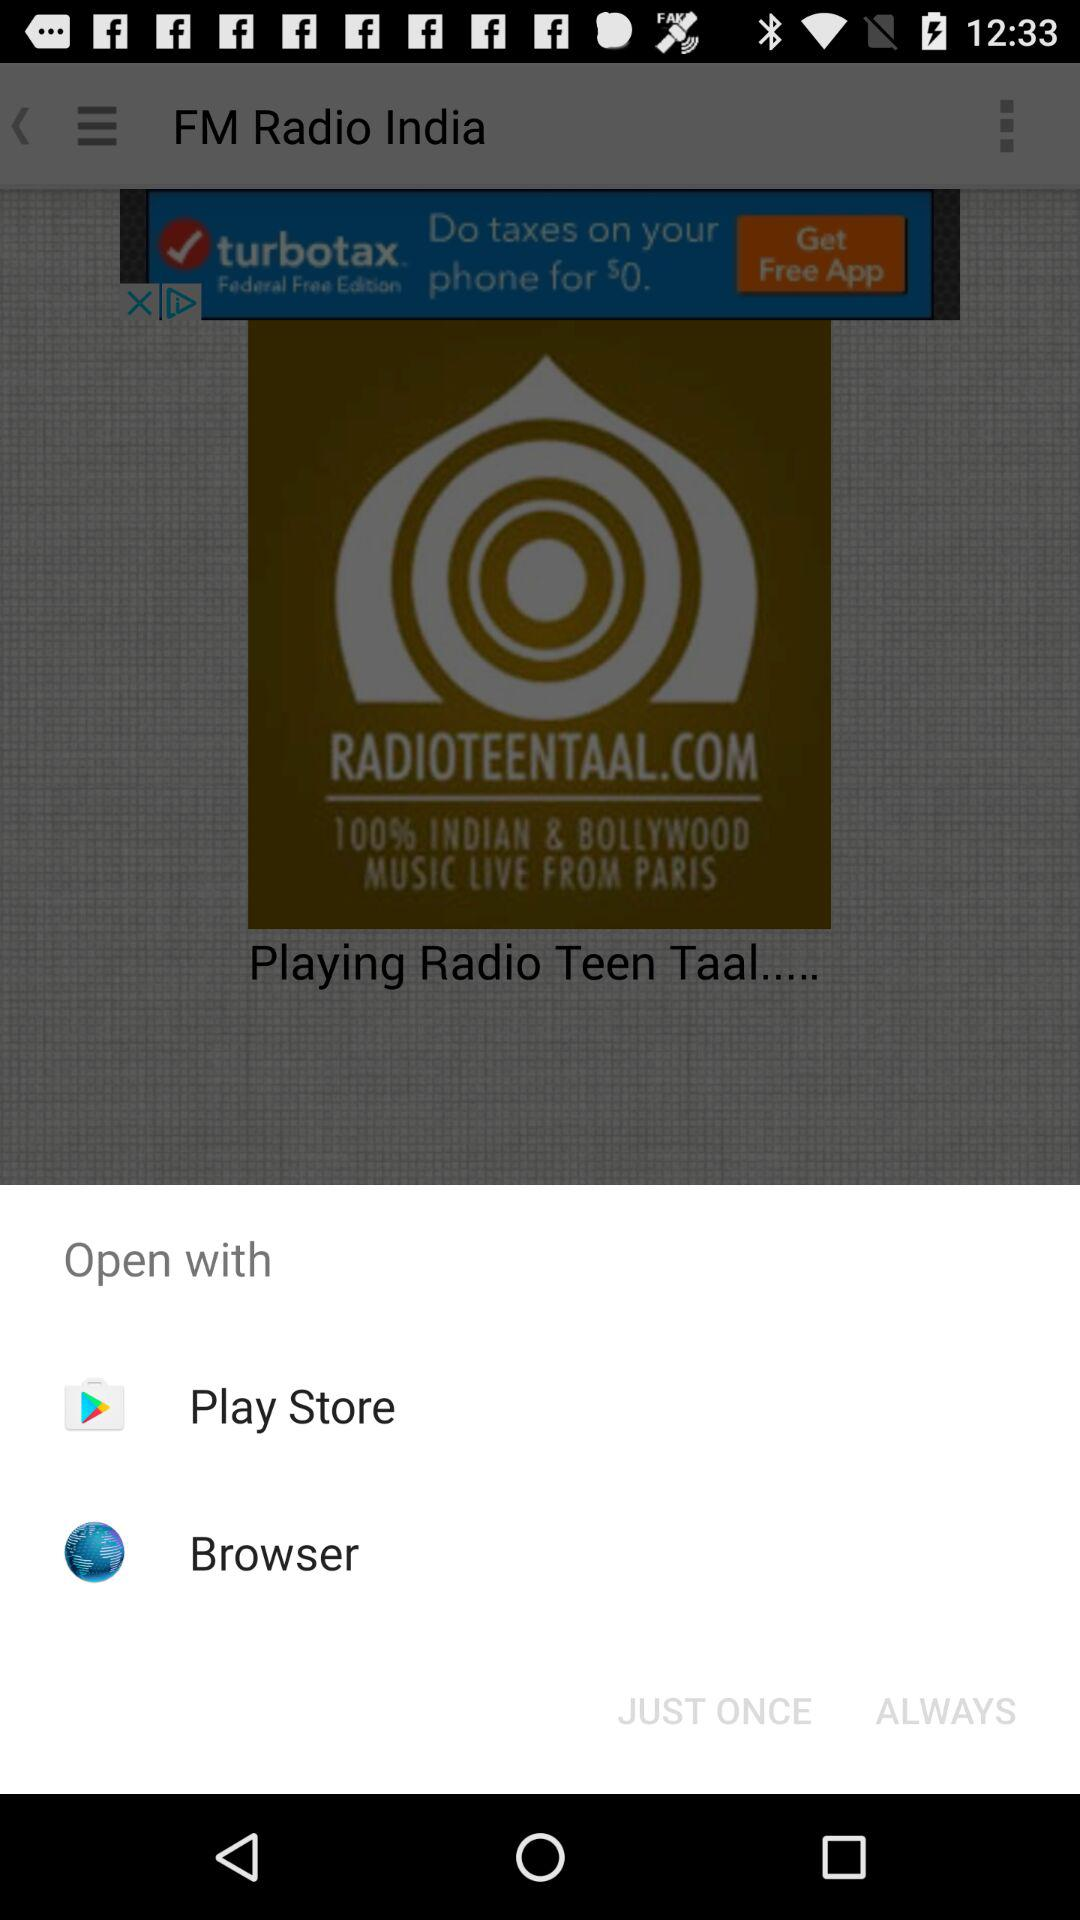How long is the track currently playing?
When the provided information is insufficient, respond with <no answer>. <no answer> 